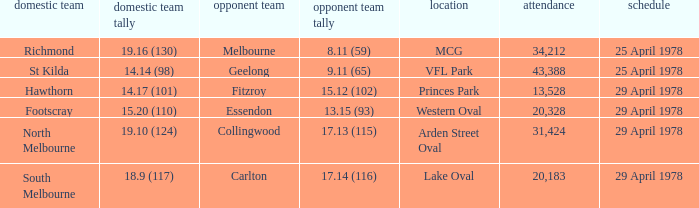In what venue was the hosted away team Essendon? Western Oval. 